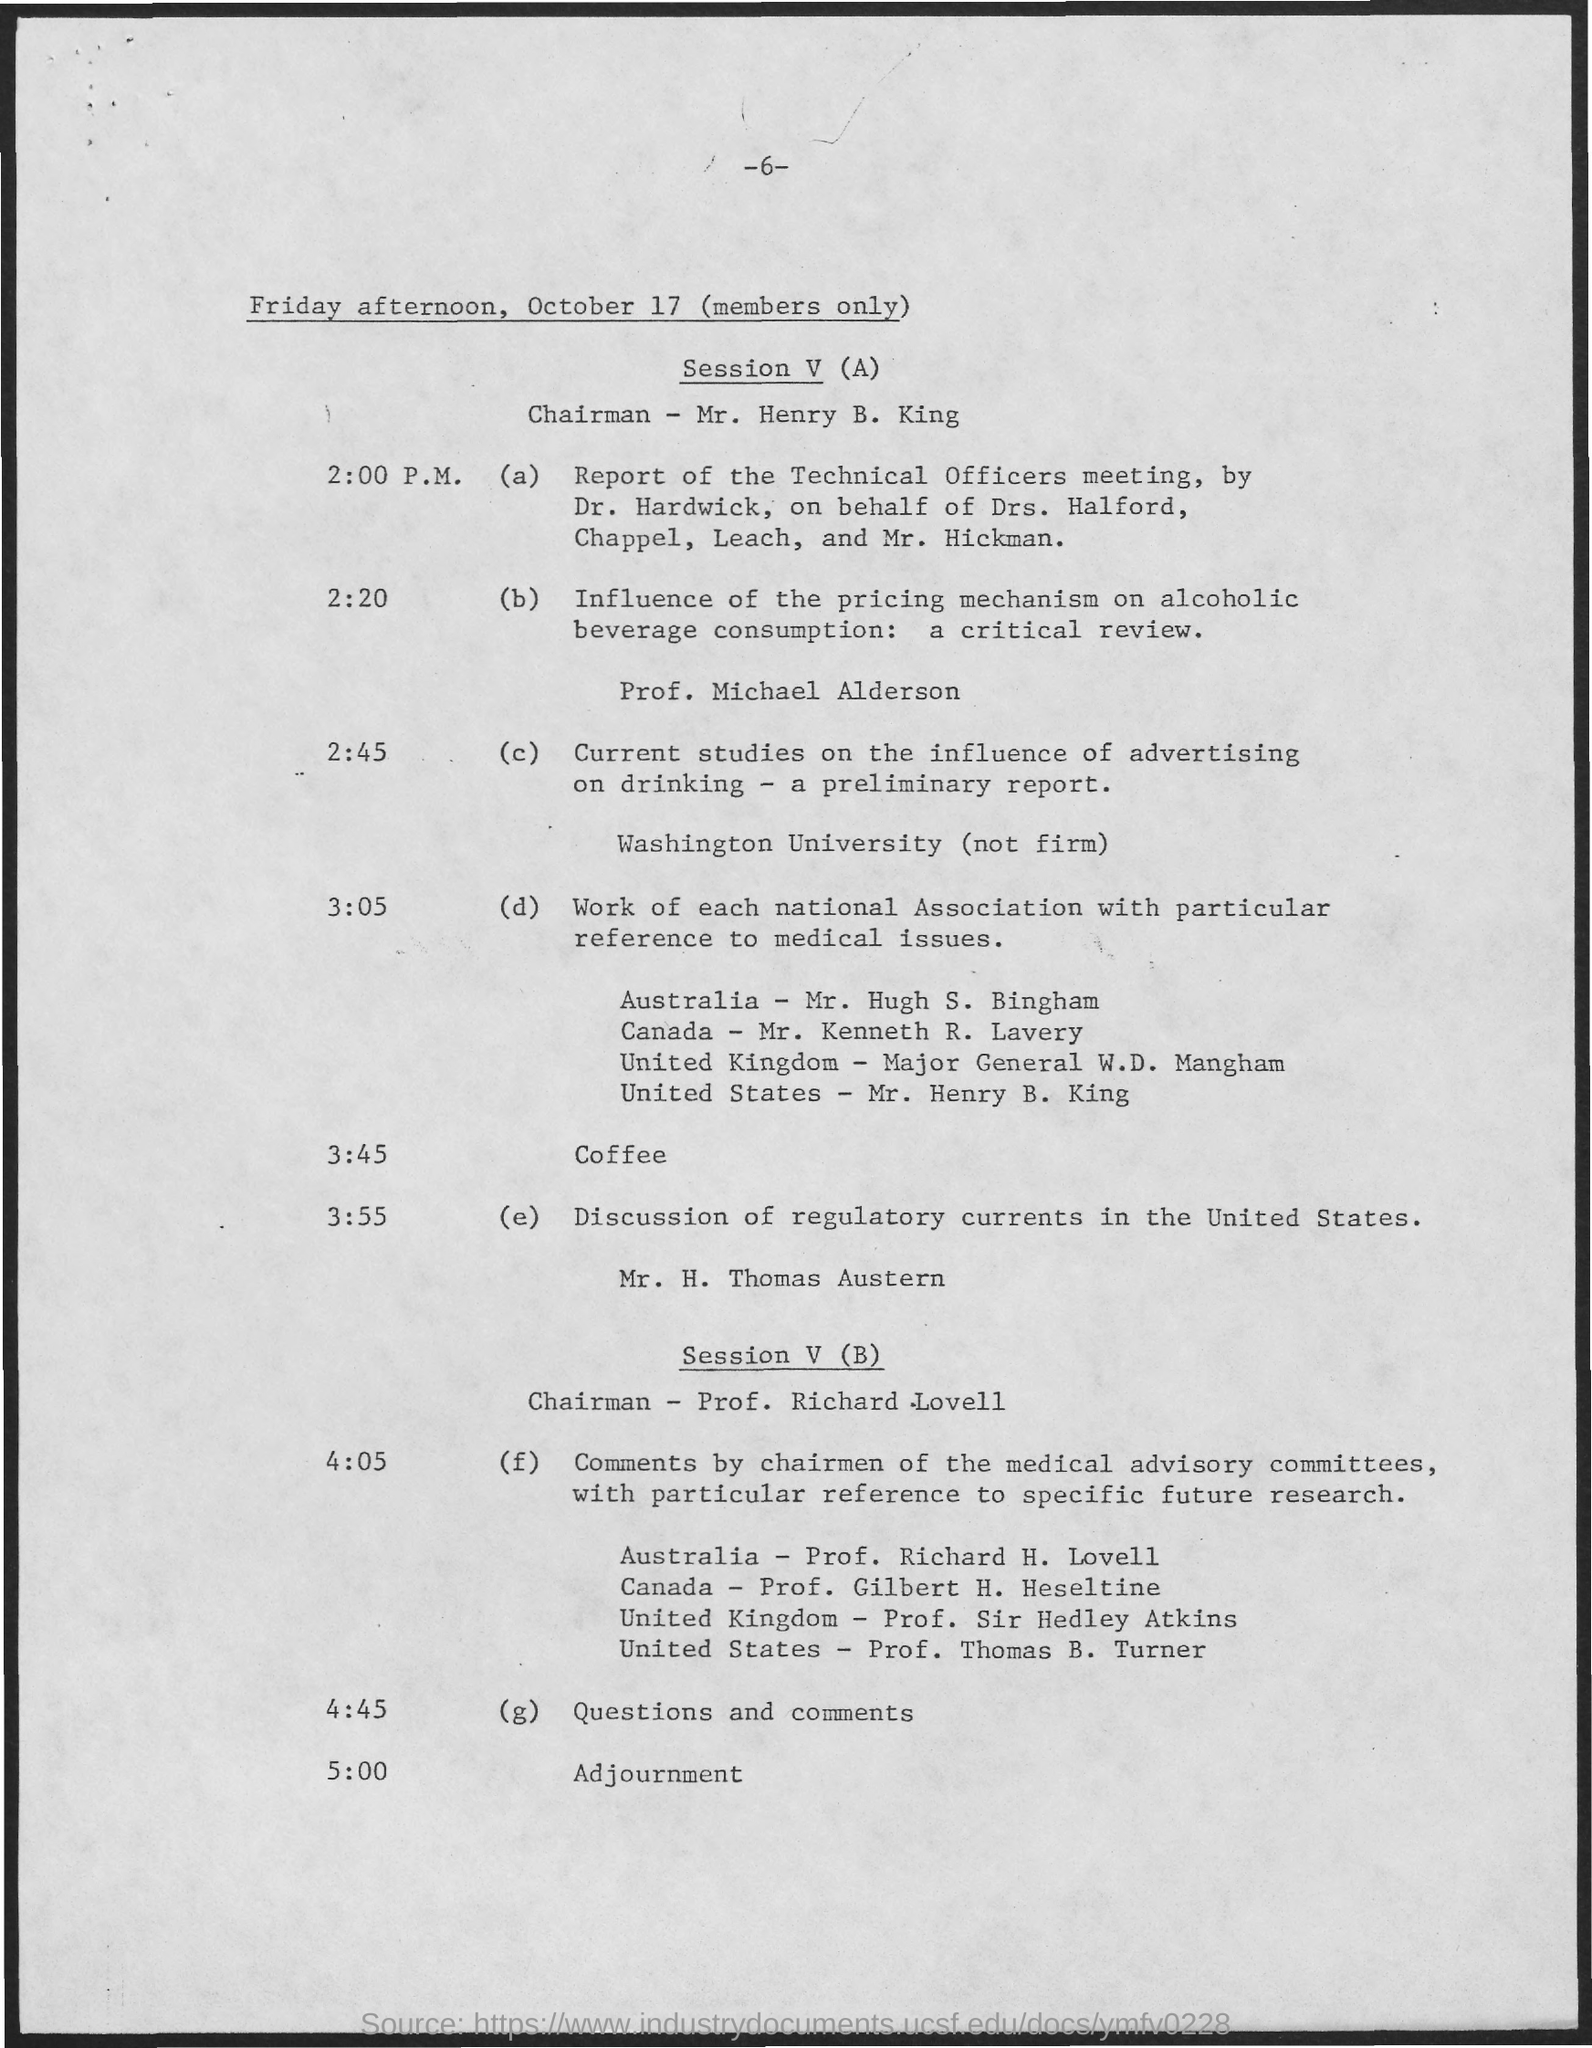List a handful of essential elements in this visual. The program at 3:55 features a discussion of regulatory currents in the United States. The chairman for Session V (A) on October 17 is Mr. Henry B. King. The page number on this document is 6, as indicated by the -6 following it. The event at 5:00 p.m. is adjournment. 